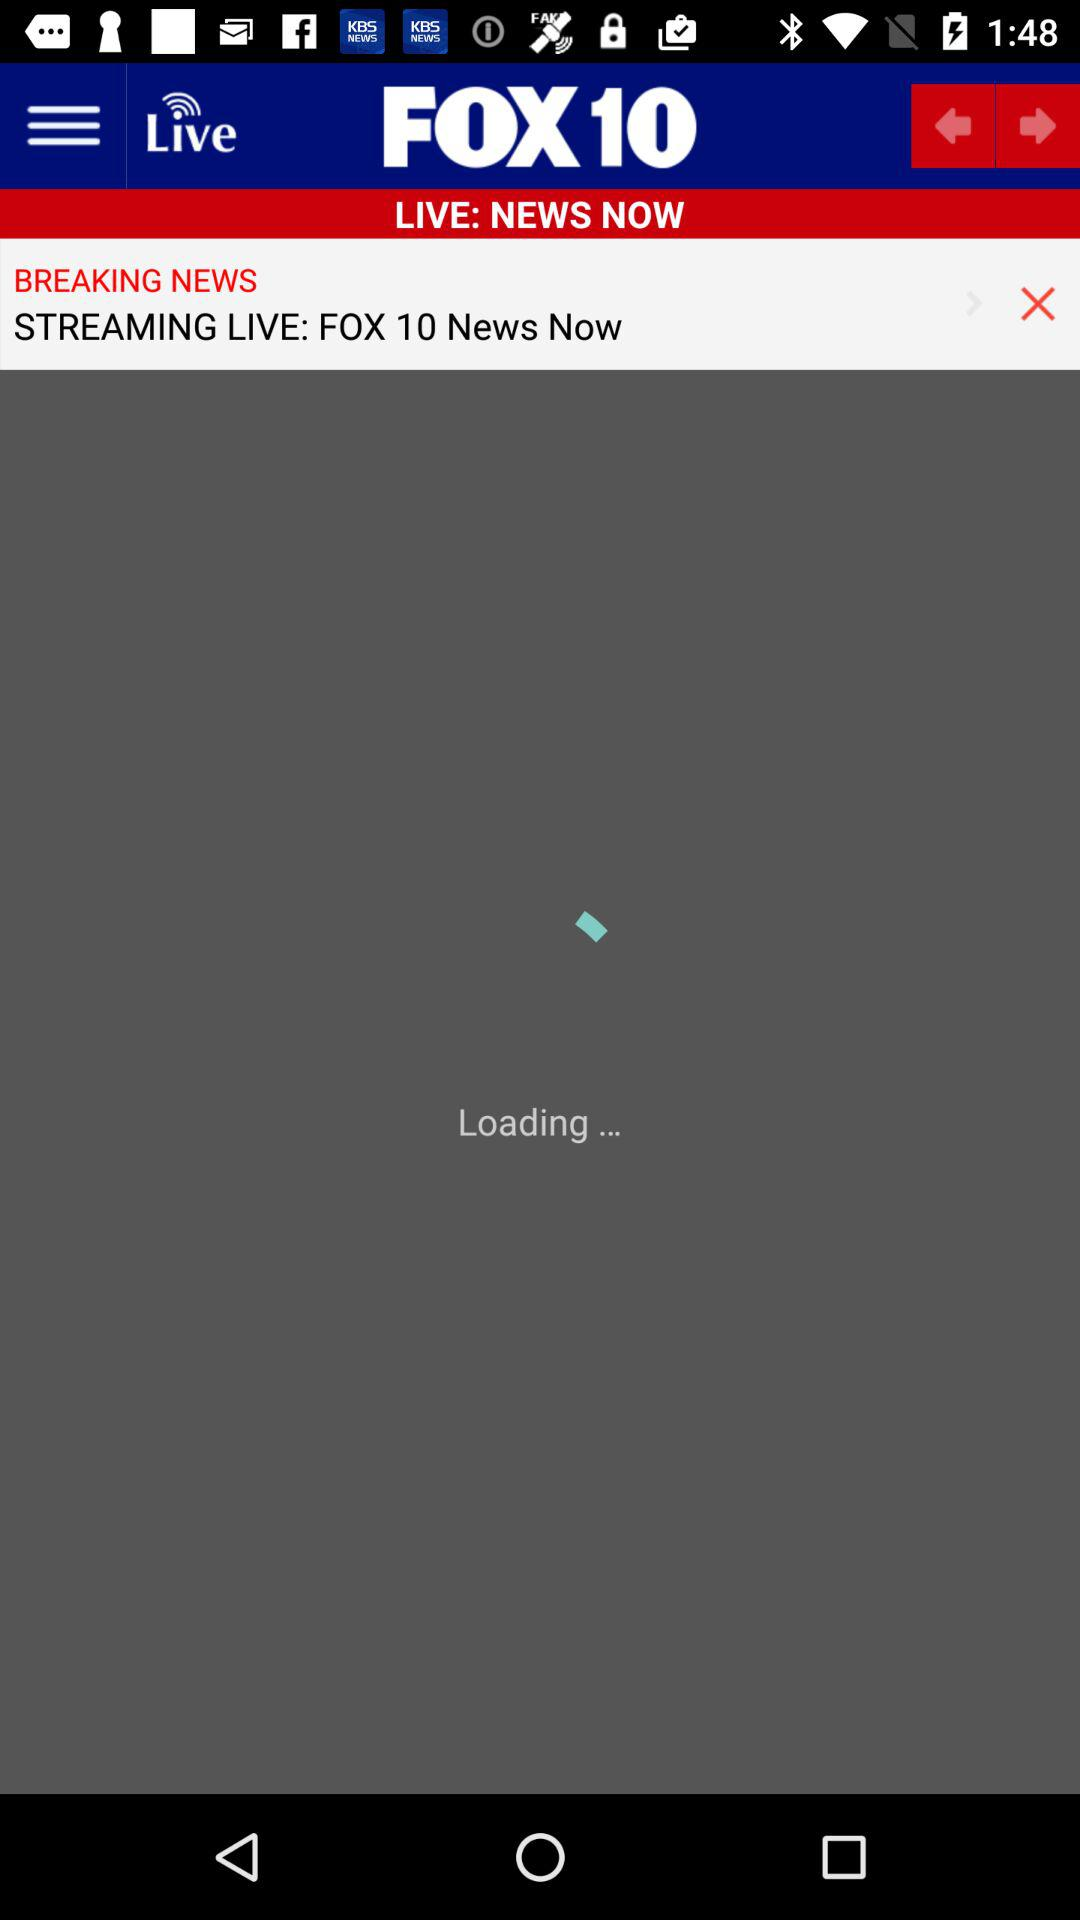What is the application name? The application name is "FOX10". 